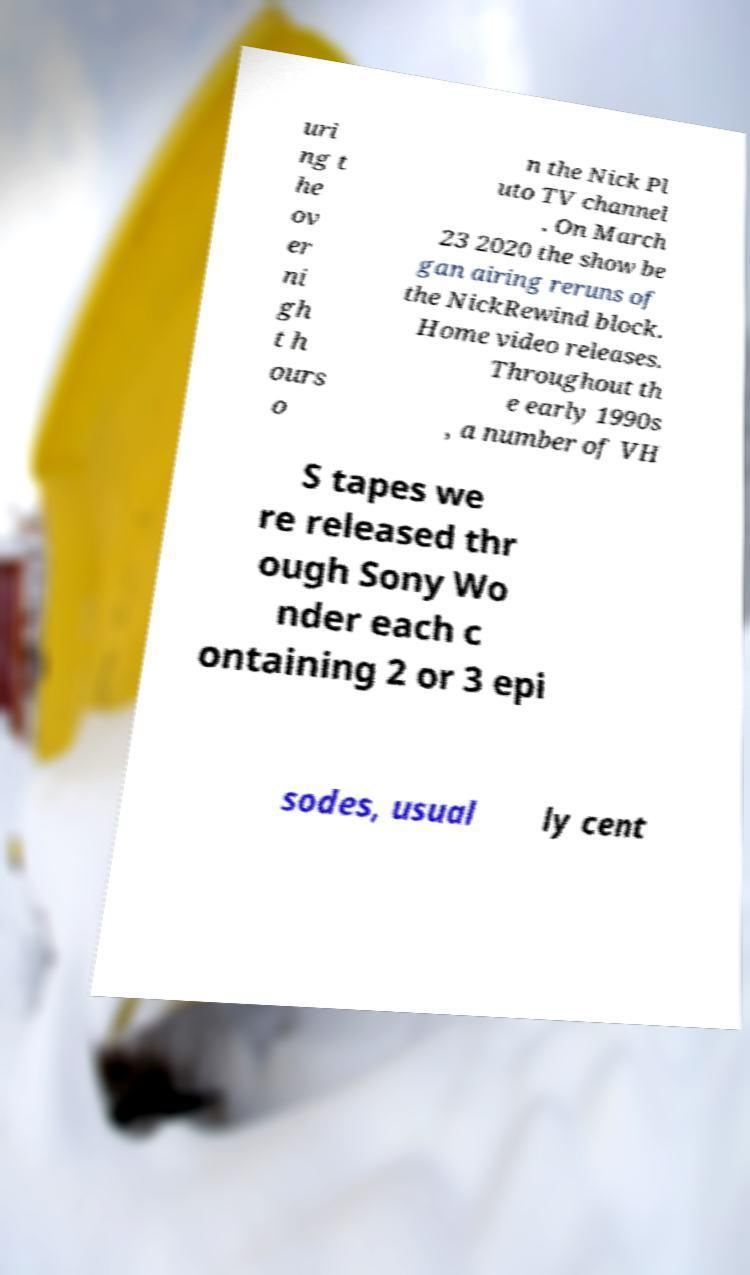What messages or text are displayed in this image? I need them in a readable, typed format. uri ng t he ov er ni gh t h ours o n the Nick Pl uto TV channel . On March 23 2020 the show be gan airing reruns of the NickRewind block. Home video releases. Throughout th e early 1990s , a number of VH S tapes we re released thr ough Sony Wo nder each c ontaining 2 or 3 epi sodes, usual ly cent 